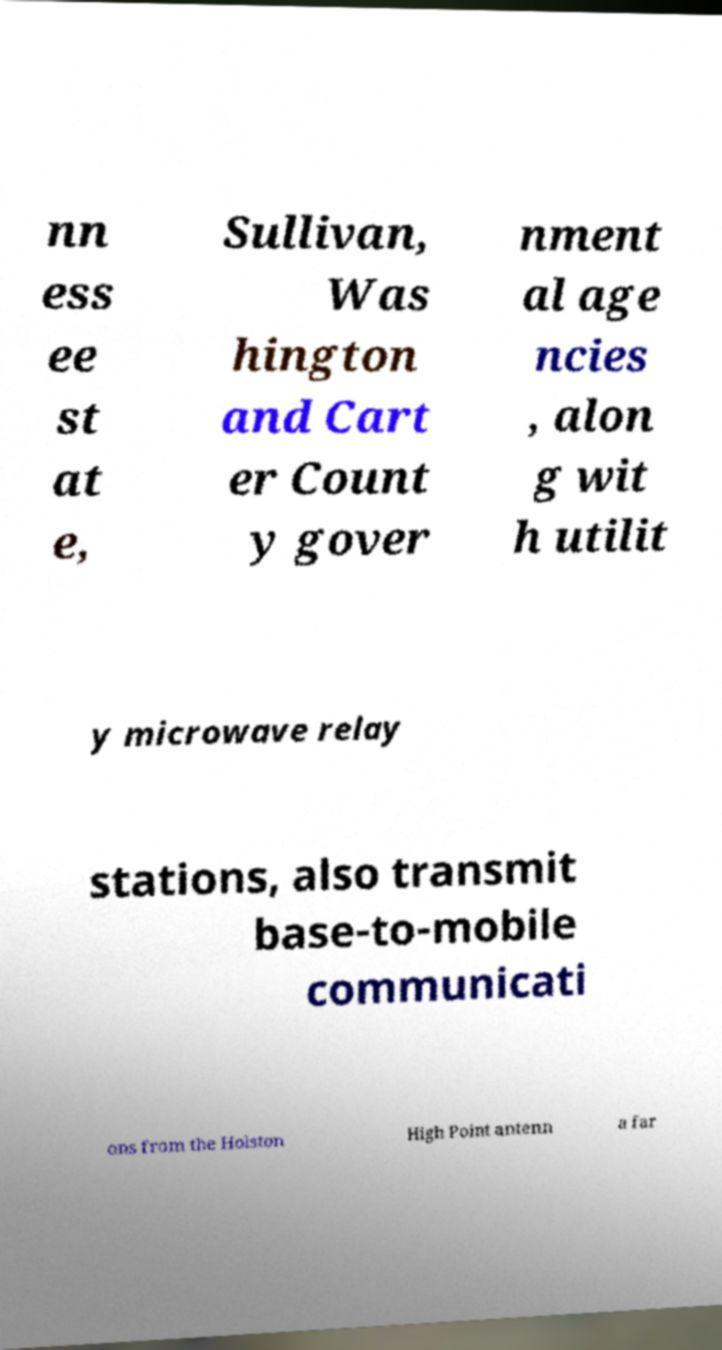Please identify and transcribe the text found in this image. nn ess ee st at e, Sullivan, Was hington and Cart er Count y gover nment al age ncies , alon g wit h utilit y microwave relay stations, also transmit base-to-mobile communicati ons from the Holston High Point antenn a far 